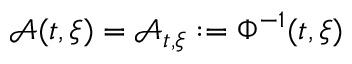Convert formula to latex. <formula><loc_0><loc_0><loc_500><loc_500>\mathcal { A } ( t , \xi ) = \mathcal { A } _ { t , \xi } \colon = \Phi ^ { - 1 } ( t , \xi )</formula> 